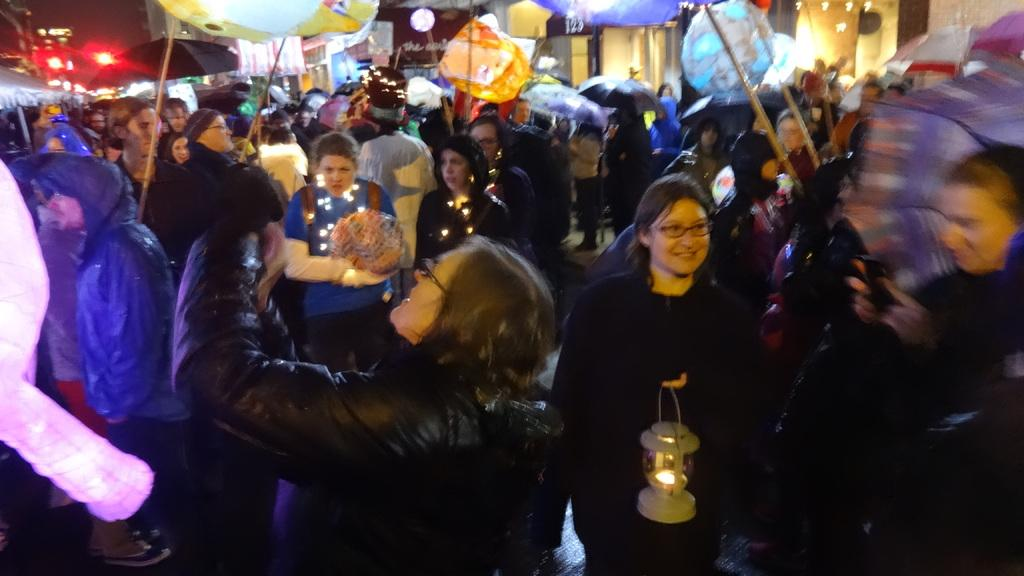How many people are in the image? There is a group of people in the image, but the exact number cannot be determined from the provided facts. What are the people holding in the image? There are umbrellas in the image, which suggests that the people might be holding them. What type of lighting is present in the image? There are lights in the image, and a lantern is also visible. What other objects can be seen in the image besides the people, umbrellas, lantern, and lights? There are other objects present in the image, but their specific nature cannot be determined from the provided facts. Can you tell me how many strings are attached to the snail in the image? There is no snail present in the image, and therefore no strings can be attached to it. 